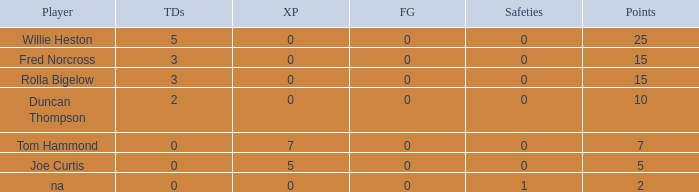How many Touchdowns have a Player of rolla bigelow, and an Extra points smaller than 0? None. 